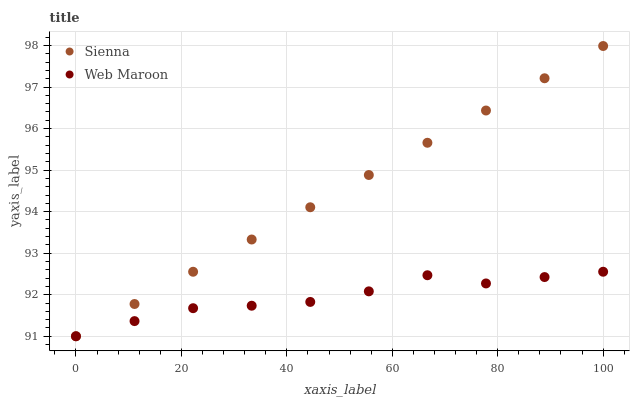Does Web Maroon have the minimum area under the curve?
Answer yes or no. Yes. Does Sienna have the maximum area under the curve?
Answer yes or no. Yes. Does Web Maroon have the maximum area under the curve?
Answer yes or no. No. Is Sienna the smoothest?
Answer yes or no. Yes. Is Web Maroon the roughest?
Answer yes or no. Yes. Is Web Maroon the smoothest?
Answer yes or no. No. Does Sienna have the lowest value?
Answer yes or no. Yes. Does Sienna have the highest value?
Answer yes or no. Yes. Does Web Maroon have the highest value?
Answer yes or no. No. Does Sienna intersect Web Maroon?
Answer yes or no. Yes. Is Sienna less than Web Maroon?
Answer yes or no. No. Is Sienna greater than Web Maroon?
Answer yes or no. No. 